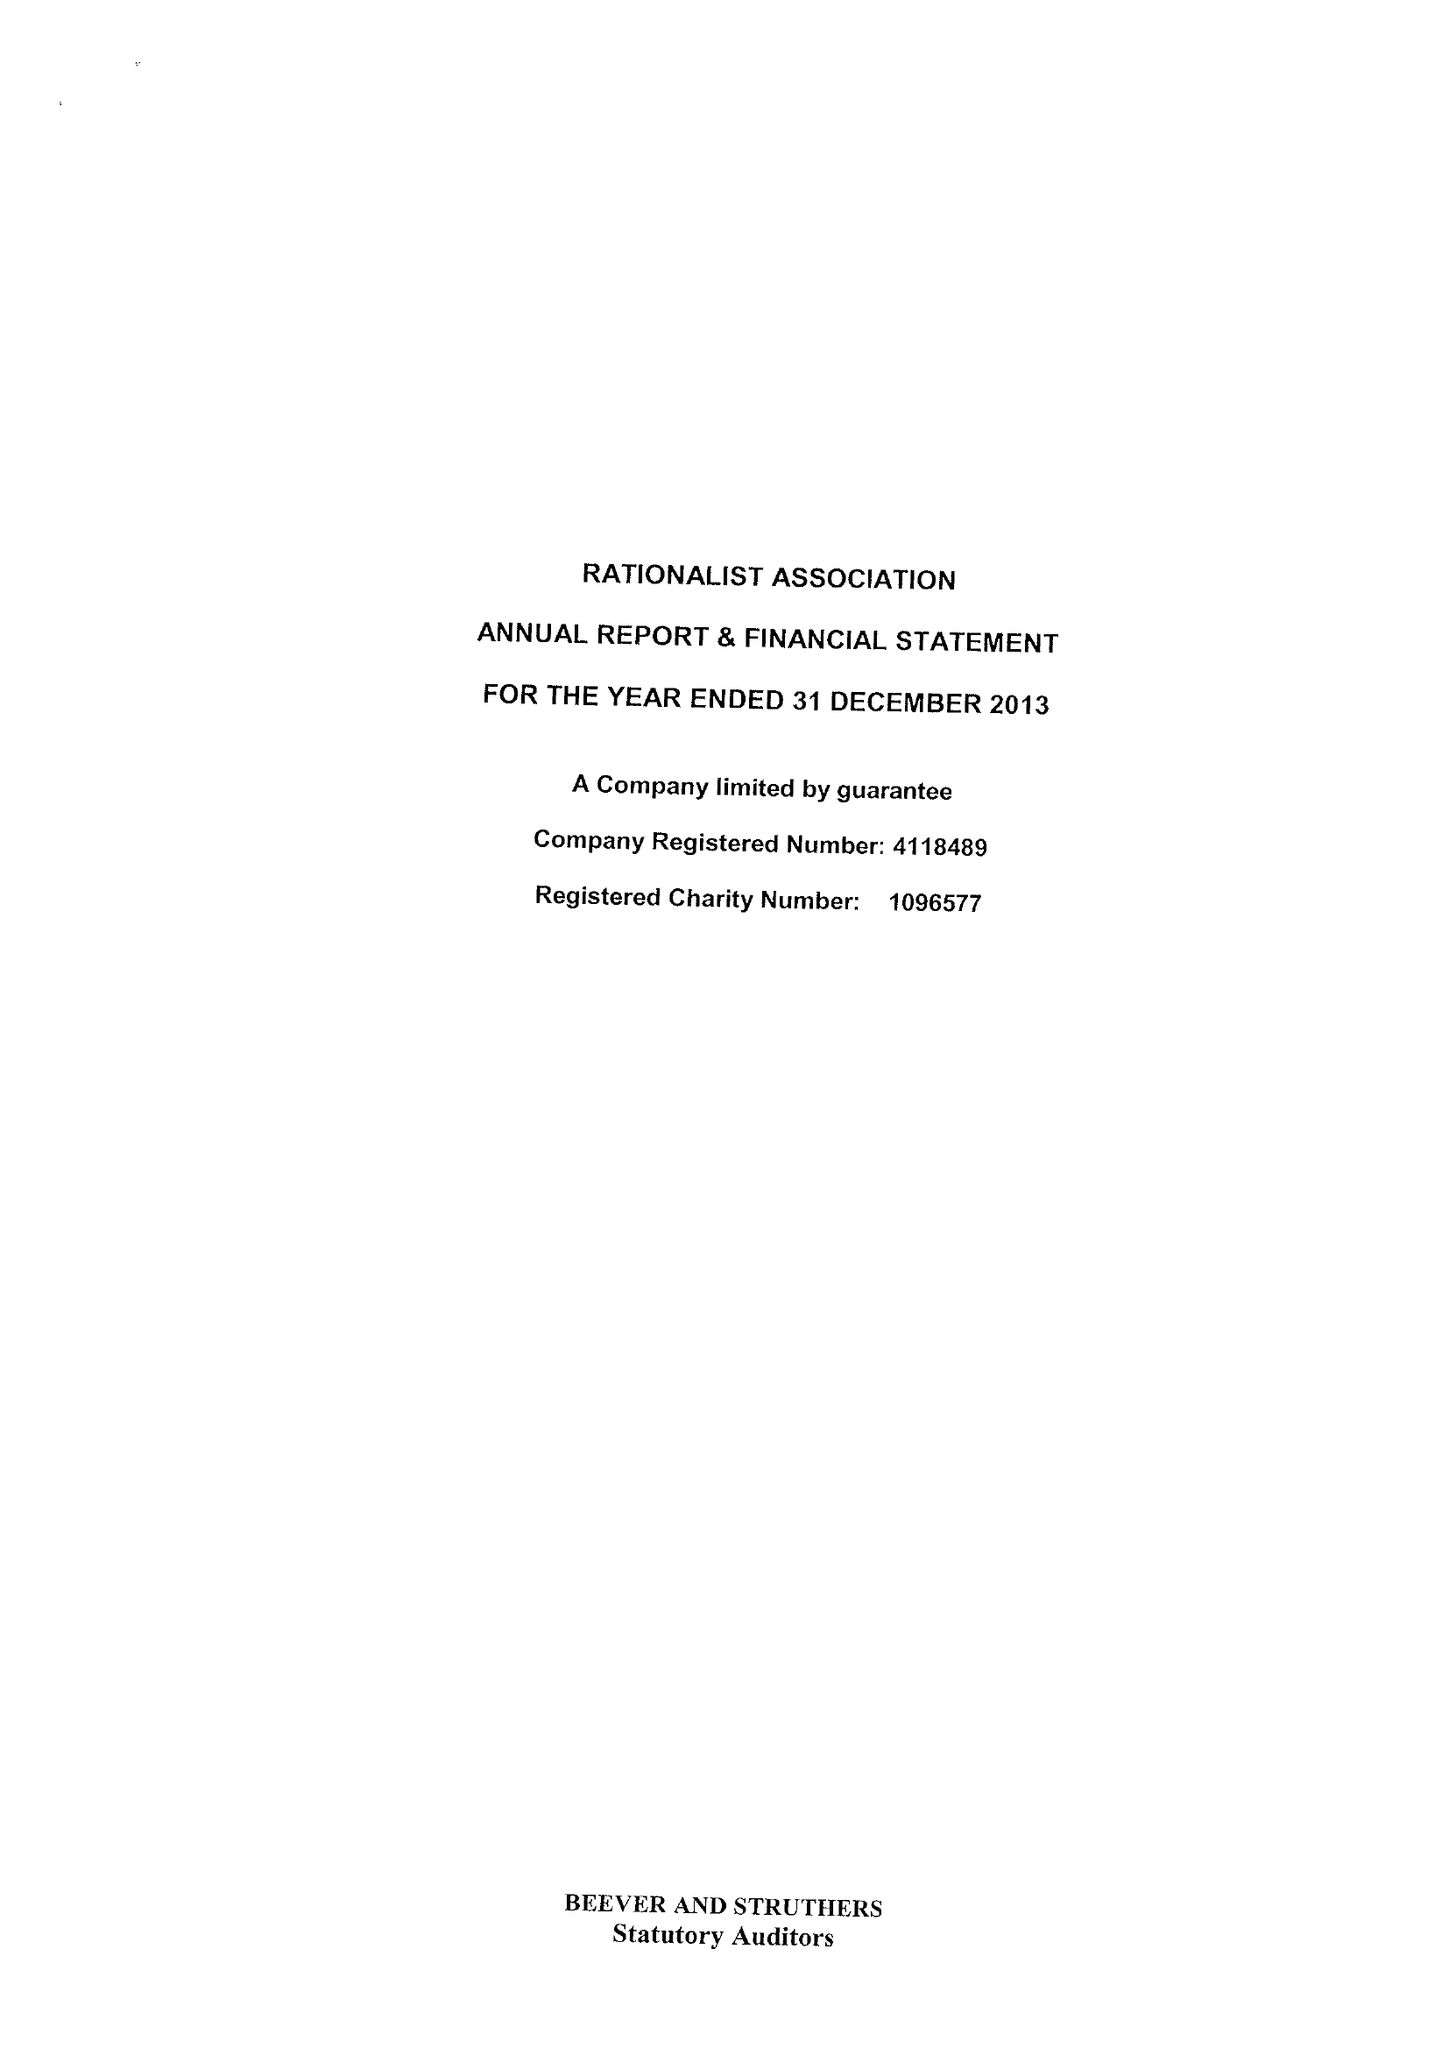What is the value for the charity_number?
Answer the question using a single word or phrase. 1096577 